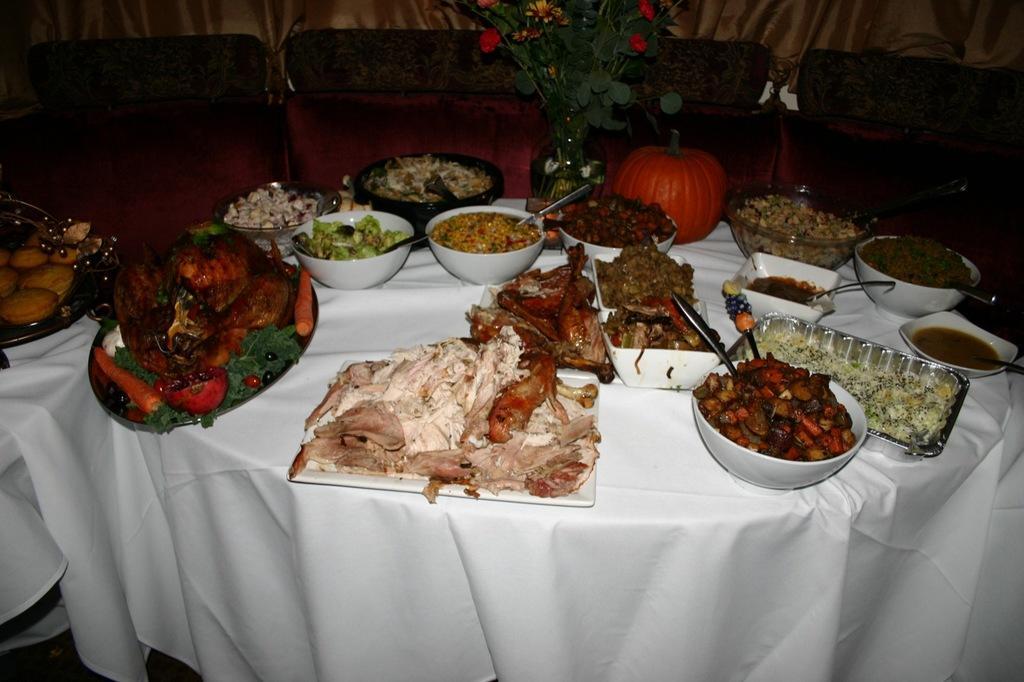How would you summarize this image in a sentence or two? In the foreground of this image, there are food items on the platters, bowls and trays on the tables. We can also see a flower vase and a pumpkin on the table. At the top, there are couches and the curtain. 